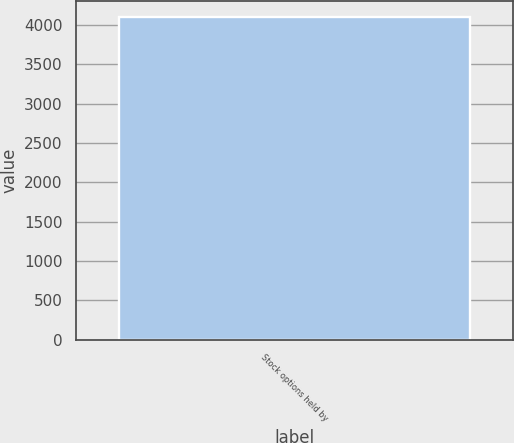<chart> <loc_0><loc_0><loc_500><loc_500><bar_chart><fcel>Stock options held by<nl><fcel>4094<nl></chart> 